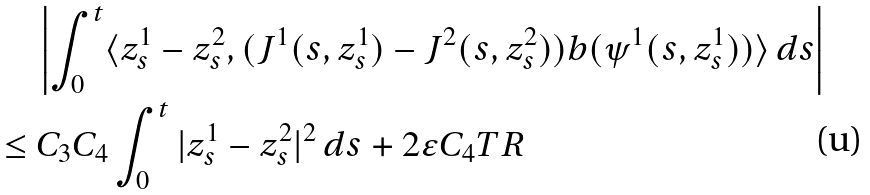<formula> <loc_0><loc_0><loc_500><loc_500>& \left | \int _ { 0 } ^ { t } \langle z ^ { 1 } _ { s } - z ^ { 2 } _ { s } , ( J ^ { 1 } ( s , z ^ { 1 } _ { s } ) - J ^ { 2 } ( s , z ^ { 2 } _ { s } ) ) b ( \psi ^ { 1 } ( s , z ^ { 1 } _ { s } ) ) \rangle \, d s \right | \\ \leq \ & C _ { 3 } C _ { 4 } \int _ { 0 } ^ { t } | z ^ { 1 } _ { s } - z ^ { 2 } _ { s } | ^ { 2 } \, d s + 2 \varepsilon C _ { 4 } T R</formula> 